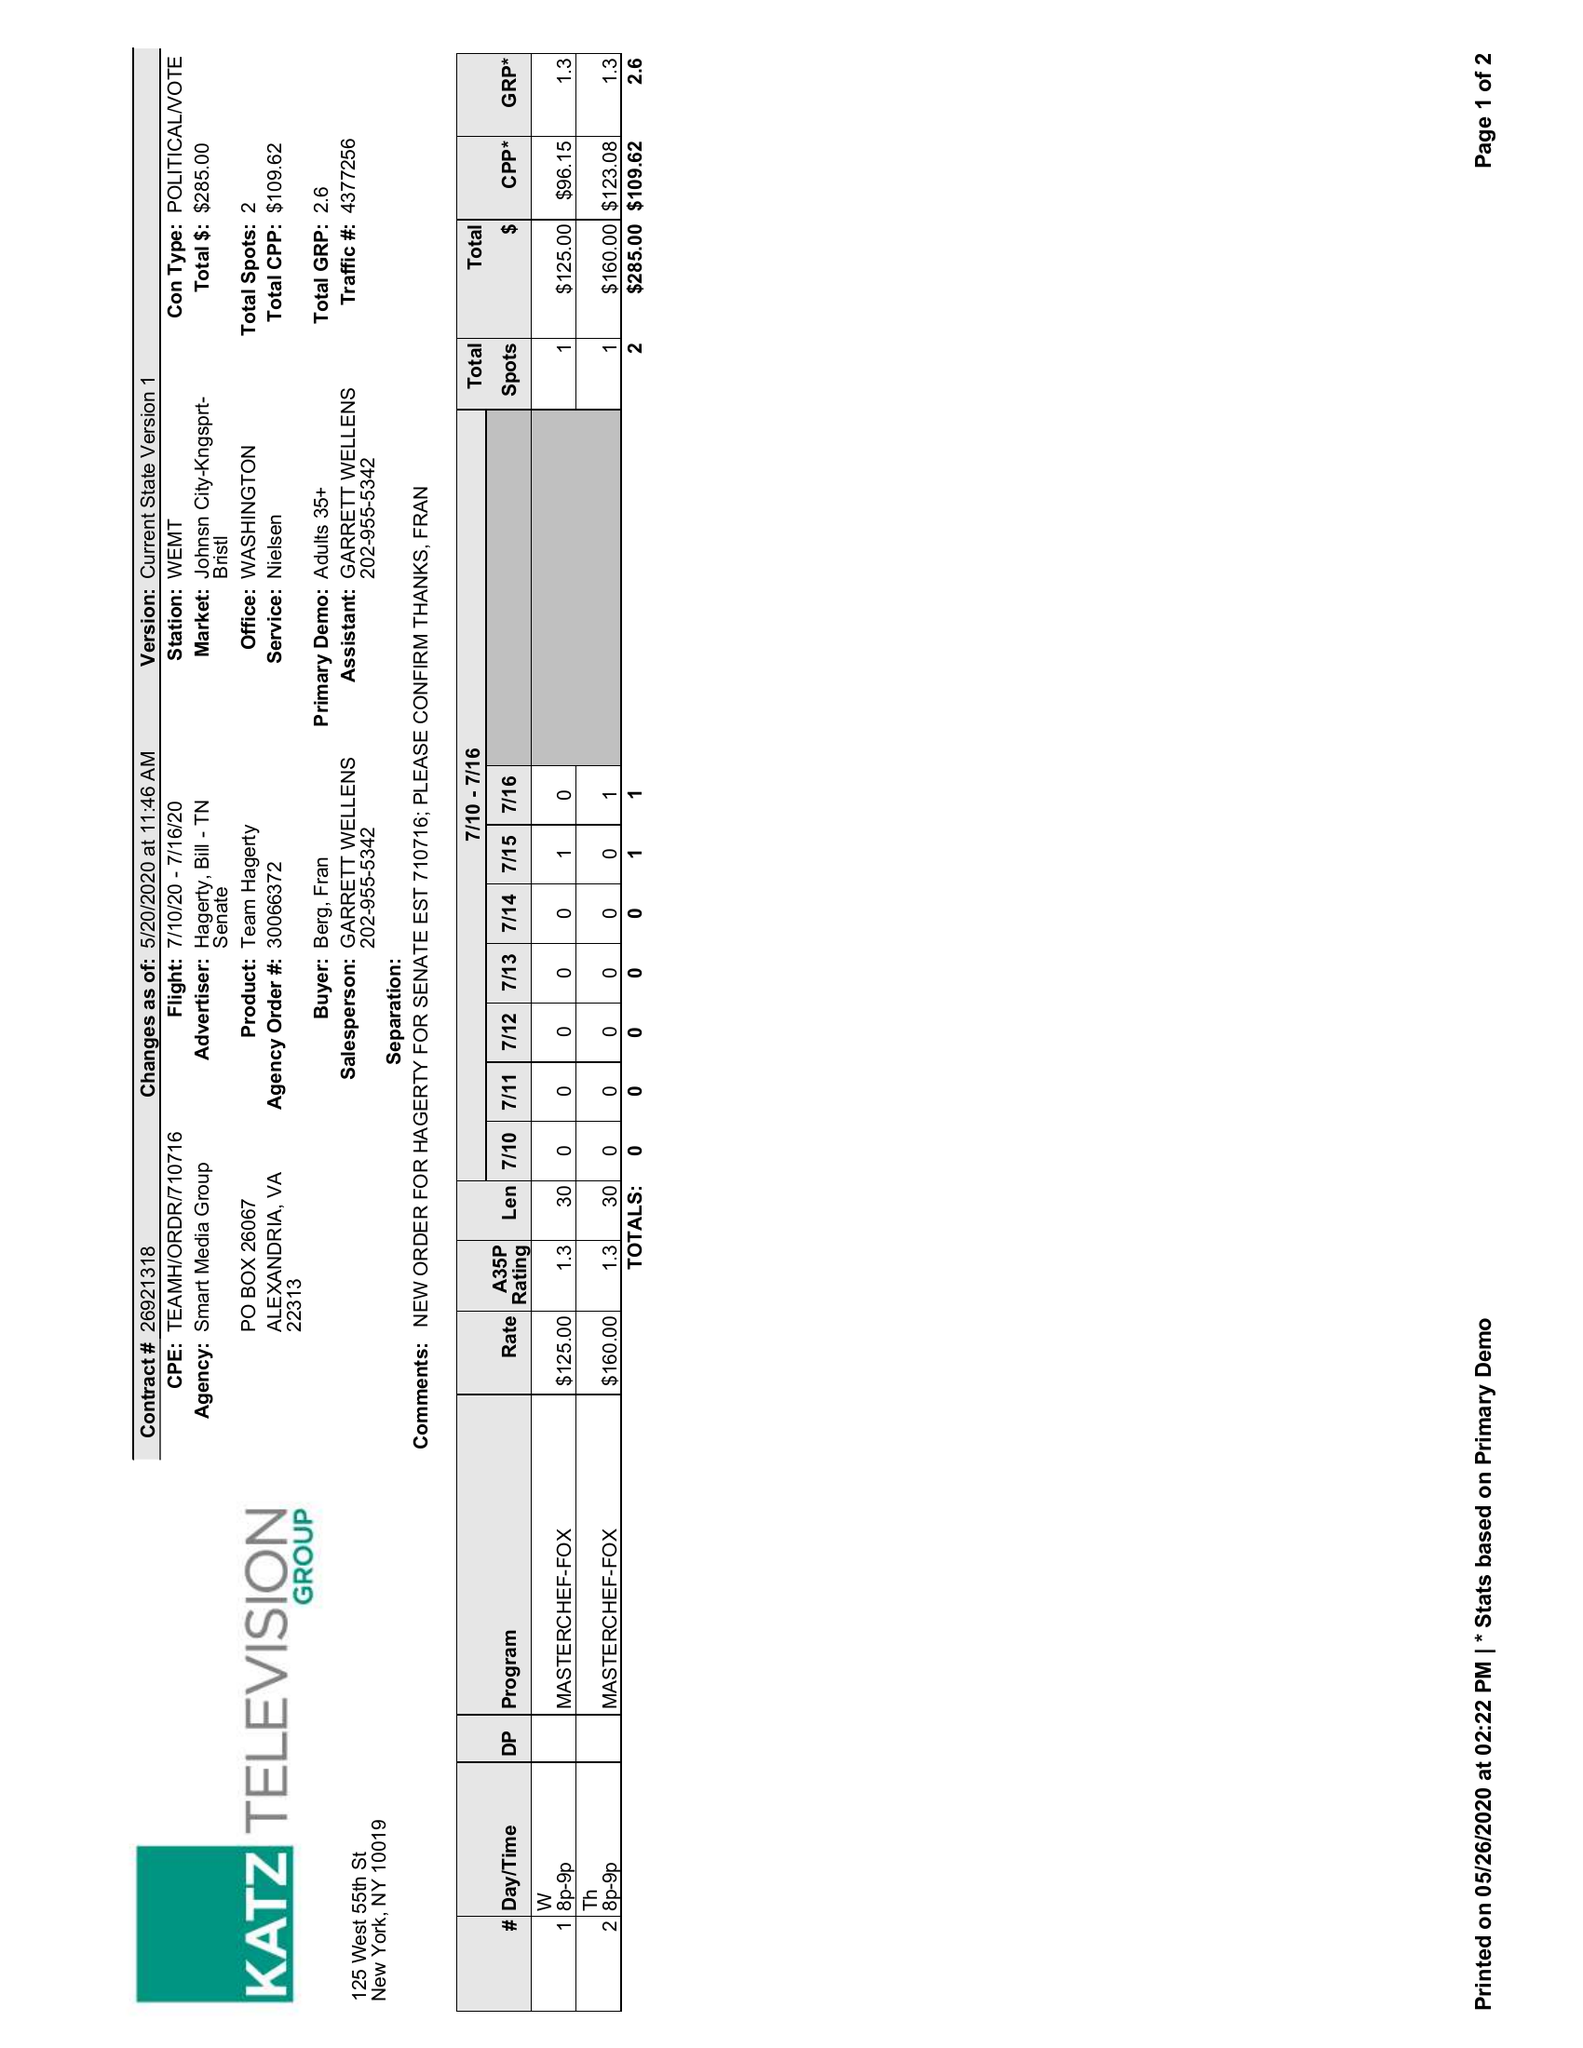What is the value for the contract_num?
Answer the question using a single word or phrase. 26921318 